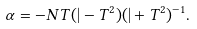<formula> <loc_0><loc_0><loc_500><loc_500>\alpha = - N T ( | - T ^ { 2 } ) ( | + T ^ { 2 } ) ^ { - 1 } .</formula> 